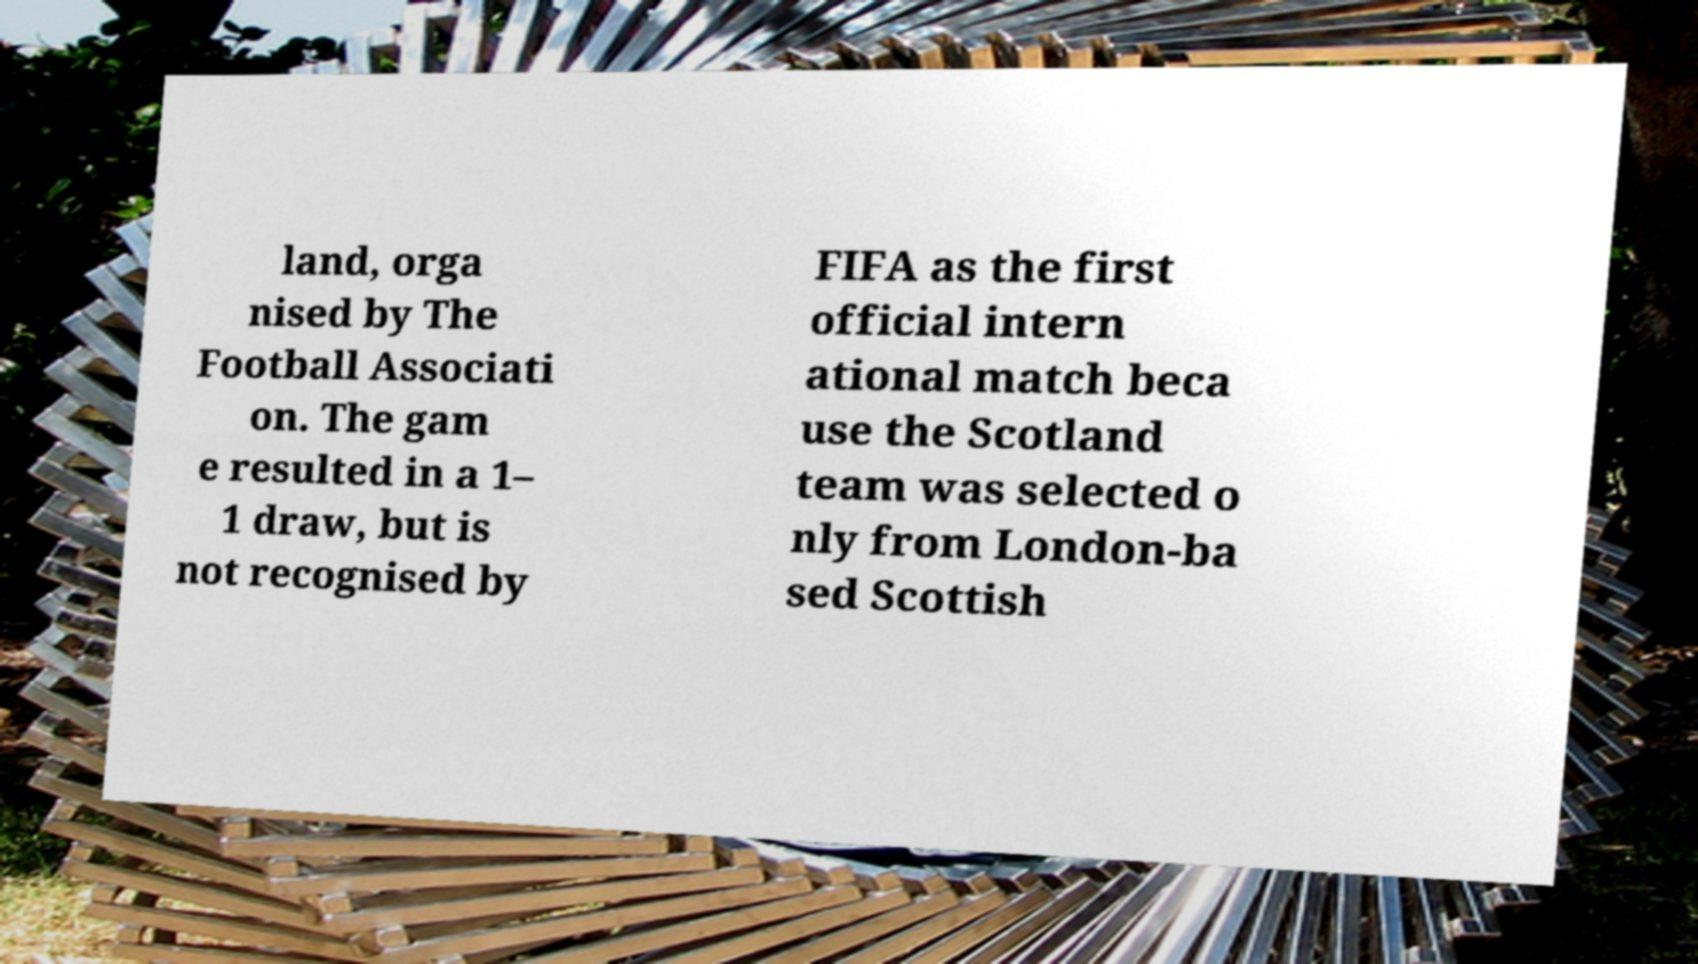Could you assist in decoding the text presented in this image and type it out clearly? land, orga nised by The Football Associati on. The gam e resulted in a 1– 1 draw, but is not recognised by FIFA as the first official intern ational match beca use the Scotland team was selected o nly from London-ba sed Scottish 